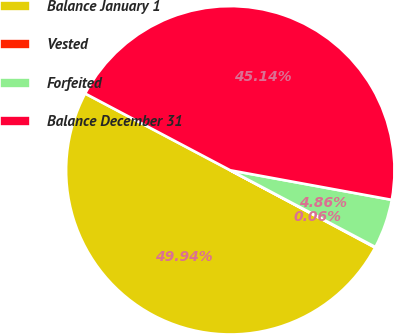Convert chart to OTSL. <chart><loc_0><loc_0><loc_500><loc_500><pie_chart><fcel>Balance January 1<fcel>Vested<fcel>Forfeited<fcel>Balance December 31<nl><fcel>49.94%<fcel>0.06%<fcel>4.86%<fcel>45.14%<nl></chart> 